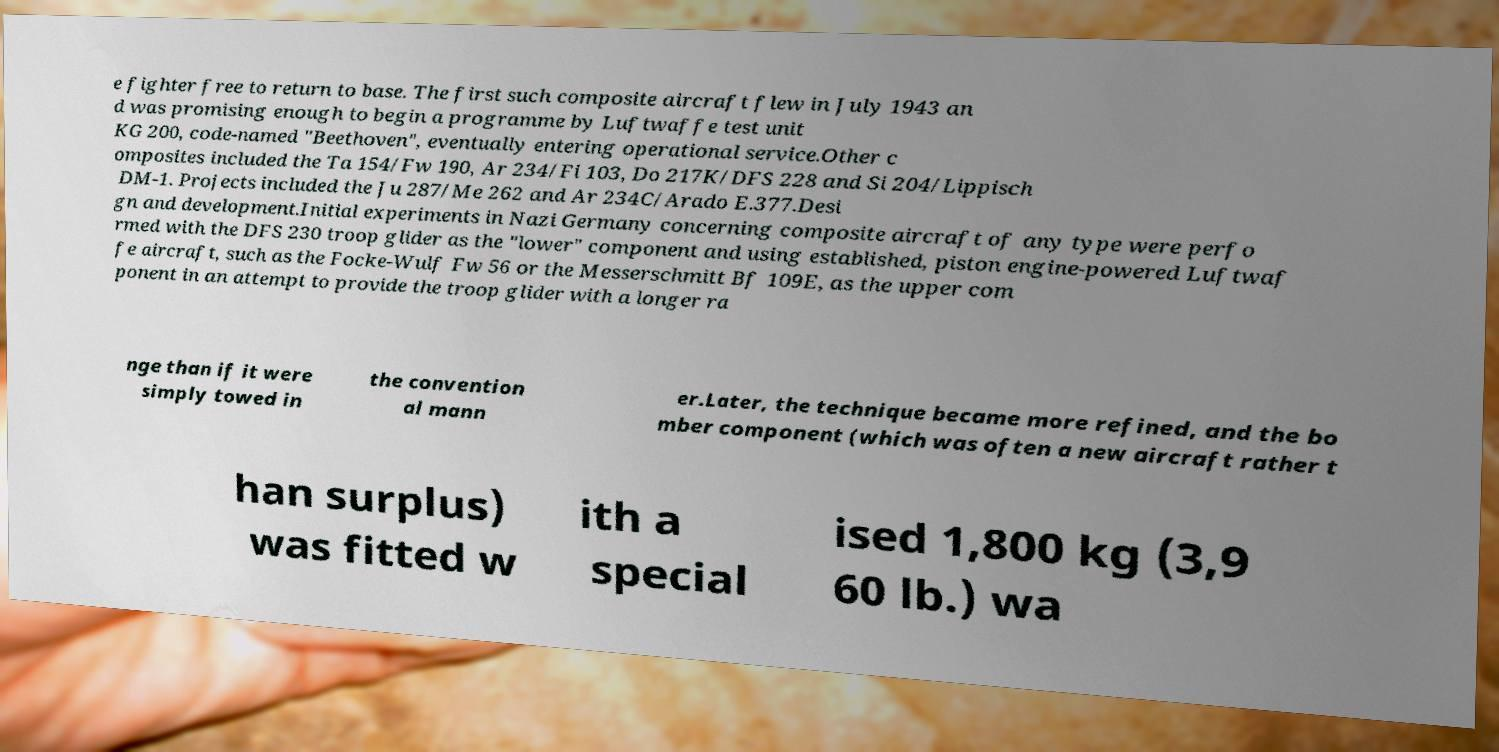Can you read and provide the text displayed in the image?This photo seems to have some interesting text. Can you extract and type it out for me? e fighter free to return to base. The first such composite aircraft flew in July 1943 an d was promising enough to begin a programme by Luftwaffe test unit KG 200, code-named "Beethoven", eventually entering operational service.Other c omposites included the Ta 154/Fw 190, Ar 234/Fi 103, Do 217K/DFS 228 and Si 204/Lippisch DM-1. Projects included the Ju 287/Me 262 and Ar 234C/Arado E.377.Desi gn and development.Initial experiments in Nazi Germany concerning composite aircraft of any type were perfo rmed with the DFS 230 troop glider as the "lower" component and using established, piston engine-powered Luftwaf fe aircraft, such as the Focke-Wulf Fw 56 or the Messerschmitt Bf 109E, as the upper com ponent in an attempt to provide the troop glider with a longer ra nge than if it were simply towed in the convention al mann er.Later, the technique became more refined, and the bo mber component (which was often a new aircraft rather t han surplus) was fitted w ith a special ised 1,800 kg (3,9 60 lb.) wa 